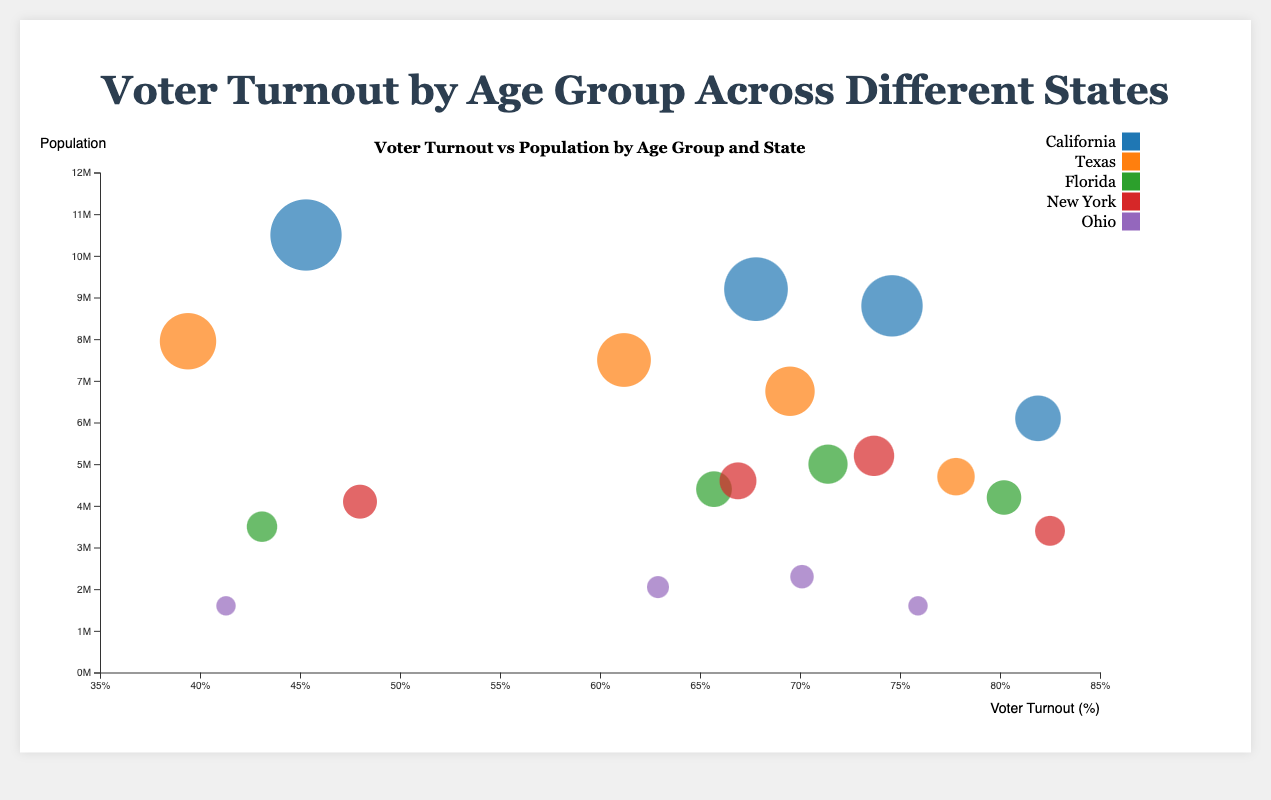What is the voter turnout percentage for the 18-29 age group in California? By looking at the bubble that represents California for the 18-29 age group, we can see its position on the x-axis, which is the Voter Turnout percentage.
Answer: 45.3% Which state has the highest voter turnout for the 65+ age group? Compare the voter turnout percentages for the 65+ age group across all states. The bubble representing New York for the 65+ age group is the furthest to the right on the x-axis, indicating the highest turnout.
Answer: New York Which age group in Ohio has the lowest voter turnout? Identify the bubbles for Ohio and compare their positions on the x-axis. The bubble representing the 18-29 age group is the furthest to the left, indicating the lowest turnout.
Answer: 18-29 What is the average voter turnout for the age groups 45-64 and 65+ in Florida? Find the voter turnout percentages for 45-64 and 65+ age groups in Florida (71.4% and 80.2% respectively). Sum these percentages and divide by 2 to find the average: (71.4 + 80.2) / 2 = 75.8.
Answer: 75.8% Which state has the largest population for the 30-44 age group, and what is its voter turnout percentage? Compare the population sizes by looking at bubble sizes for the 30-44 age group across all states. California has the largest bubble, so the population is largest there. Its voter turnout percentage is given by its position on the x-axis.
Answer: California, 67.8% In which age group does Texas have higher voter turnout compared to Ohio? Compare the x-axis positions of Texas and Ohio's bubbles across all age groups. The bubbles for Texas are further to the right in the 30-44 and 45-64 age groups compared to Ohio, indicating higher voter turnout in these groups.
Answer: 30-44 and 45-64 What is the total population of the 65+ age group in California and New York combined? Sum the populations of the 65+ age group in California (6,100,000) and New York (3,400,000). Total population = 6,100,000 + 3,400,000 = 9,500,000.
Answer: 9,500,000 Which state has the lowest voter turnout for the 18-29 age group? Compare the voter turnout percentages for the 18-29 age group across all states. The bubble representing Texas for the 18-29 age group is the furthest to the left, indicating the lowest turnout.
Answer: Texas How does the voter turnout for the 45-64 age group in New York compare to that of California? Compare the x-axis positions of the bubbles representing the 45-64 age group in New York and California. The New York bubble is further to the right than the California bubble, indicating a higher turnout.
Answer: New York has a higher turnout By how much does the voter turnout for the 65+ age group in Ohio differ from that in Texas? Compare the voter turnout percentages for the 65+ age group in Ohio (75.9%) and Texas (77.8%). The difference is abs(75.9% - 77.8%) = 1.9%.
Answer: 1.9% 